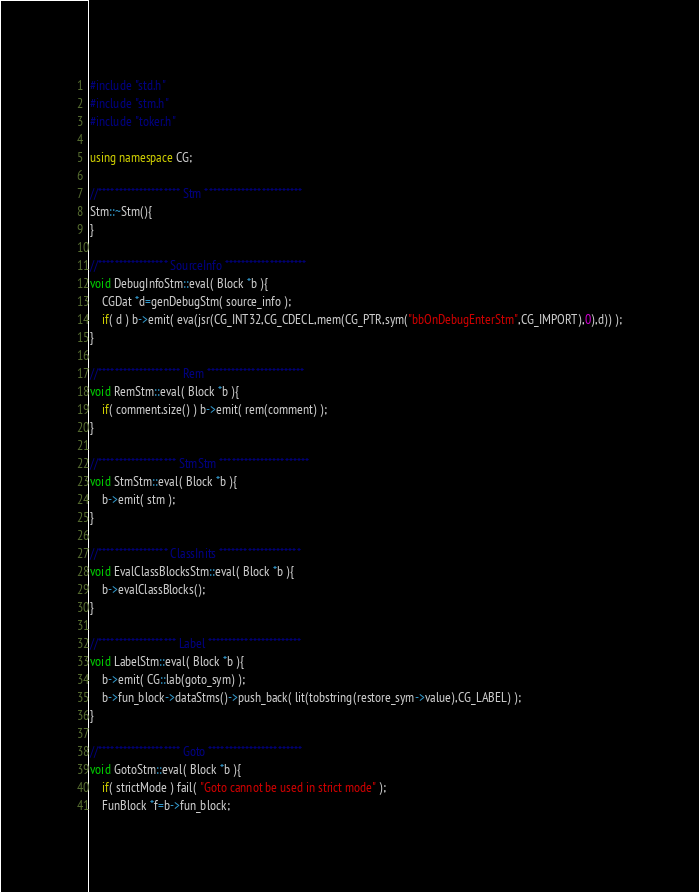Convert code to text. <code><loc_0><loc_0><loc_500><loc_500><_C++_>
#include "std.h"
#include "stm.h"
#include "toker.h"

using namespace CG;

//******************** Stm ************************
Stm::~Stm(){
}

//***************** SourceInfo ********************
void DebugInfoStm::eval( Block *b ){
	CGDat *d=genDebugStm( source_info );
	if( d ) b->emit( eva(jsr(CG_INT32,CG_CDECL,mem(CG_PTR,sym("bbOnDebugEnterStm",CG_IMPORT),0),d)) );
}

//******************** Rem ************************
void RemStm::eval( Block *b ){
	if( comment.size() ) b->emit( rem(comment) );
}

//******************* StmStm **********************
void StmStm::eval( Block *b ){
	b->emit( stm );
}

//***************** ClassInits ********************
void EvalClassBlocksStm::eval( Block *b ){
	b->evalClassBlocks();
}

//******************* Label ***********************
void LabelStm::eval( Block *b ){
	b->emit( CG::lab(goto_sym) );
	b->fun_block->dataStms()->push_back( lit(tobstring(restore_sym->value),CG_LABEL) );
}

//******************** Goto ***********************
void GotoStm::eval( Block *b ){
	if( strictMode ) fail( "Goto cannot be used in strict mode" );
	FunBlock *f=b->fun_block;</code> 